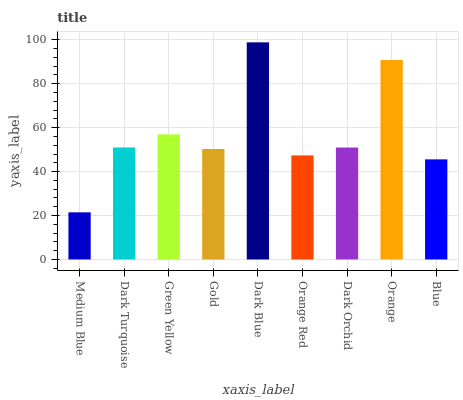Is Dark Turquoise the minimum?
Answer yes or no. No. Is Dark Turquoise the maximum?
Answer yes or no. No. Is Dark Turquoise greater than Medium Blue?
Answer yes or no. Yes. Is Medium Blue less than Dark Turquoise?
Answer yes or no. Yes. Is Medium Blue greater than Dark Turquoise?
Answer yes or no. No. Is Dark Turquoise less than Medium Blue?
Answer yes or no. No. Is Dark Orchid the high median?
Answer yes or no. Yes. Is Dark Orchid the low median?
Answer yes or no. Yes. Is Green Yellow the high median?
Answer yes or no. No. Is Gold the low median?
Answer yes or no. No. 